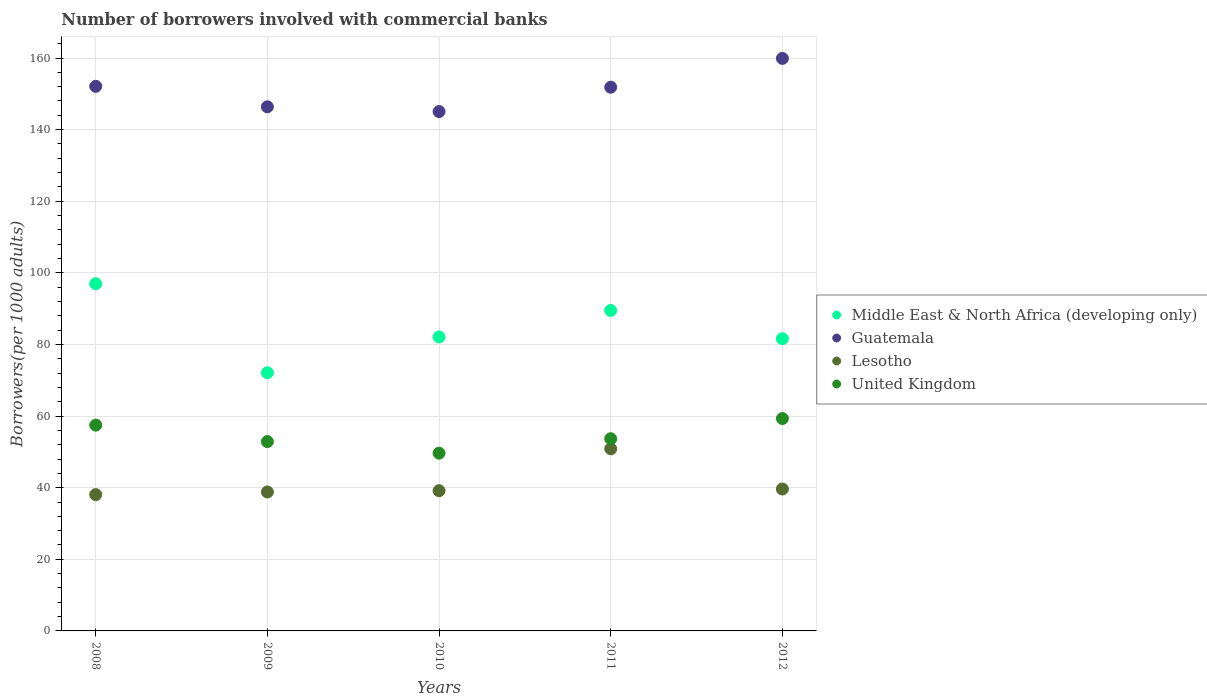How many different coloured dotlines are there?
Your response must be concise. 4. What is the number of borrowers involved with commercial banks in Guatemala in 2011?
Offer a very short reply. 151.85. Across all years, what is the maximum number of borrowers involved with commercial banks in Lesotho?
Your answer should be very brief. 50.87. Across all years, what is the minimum number of borrowers involved with commercial banks in United Kingdom?
Your response must be concise. 49.65. In which year was the number of borrowers involved with commercial banks in Lesotho minimum?
Your answer should be very brief. 2008. What is the total number of borrowers involved with commercial banks in United Kingdom in the graph?
Give a very brief answer. 273. What is the difference between the number of borrowers involved with commercial banks in Middle East & North Africa (developing only) in 2008 and that in 2010?
Provide a short and direct response. 14.86. What is the difference between the number of borrowers involved with commercial banks in Middle East & North Africa (developing only) in 2008 and the number of borrowers involved with commercial banks in Lesotho in 2012?
Ensure brevity in your answer.  57.33. What is the average number of borrowers involved with commercial banks in United Kingdom per year?
Provide a short and direct response. 54.6. In the year 2009, what is the difference between the number of borrowers involved with commercial banks in Lesotho and number of borrowers involved with commercial banks in Guatemala?
Your answer should be very brief. -107.56. In how many years, is the number of borrowers involved with commercial banks in Guatemala greater than 128?
Your answer should be very brief. 5. What is the ratio of the number of borrowers involved with commercial banks in Guatemala in 2011 to that in 2012?
Keep it short and to the point. 0.95. Is the difference between the number of borrowers involved with commercial banks in Lesotho in 2008 and 2012 greater than the difference between the number of borrowers involved with commercial banks in Guatemala in 2008 and 2012?
Provide a succinct answer. Yes. What is the difference between the highest and the second highest number of borrowers involved with commercial banks in Lesotho?
Offer a very short reply. 11.24. What is the difference between the highest and the lowest number of borrowers involved with commercial banks in Middle East & North Africa (developing only)?
Offer a terse response. 24.86. Is it the case that in every year, the sum of the number of borrowers involved with commercial banks in Lesotho and number of borrowers involved with commercial banks in Middle East & North Africa (developing only)  is greater than the sum of number of borrowers involved with commercial banks in United Kingdom and number of borrowers involved with commercial banks in Guatemala?
Give a very brief answer. No. Is the number of borrowers involved with commercial banks in Lesotho strictly greater than the number of borrowers involved with commercial banks in Middle East & North Africa (developing only) over the years?
Make the answer very short. No. Does the graph contain grids?
Make the answer very short. Yes. What is the title of the graph?
Your answer should be compact. Number of borrowers involved with commercial banks. Does "Turkey" appear as one of the legend labels in the graph?
Offer a terse response. No. What is the label or title of the Y-axis?
Your answer should be compact. Borrowers(per 1000 adults). What is the Borrowers(per 1000 adults) of Middle East & North Africa (developing only) in 2008?
Provide a succinct answer. 96.96. What is the Borrowers(per 1000 adults) of Guatemala in 2008?
Make the answer very short. 152.09. What is the Borrowers(per 1000 adults) of Lesotho in 2008?
Provide a short and direct response. 38.07. What is the Borrowers(per 1000 adults) of United Kingdom in 2008?
Provide a succinct answer. 57.47. What is the Borrowers(per 1000 adults) in Middle East & North Africa (developing only) in 2009?
Keep it short and to the point. 72.11. What is the Borrowers(per 1000 adults) of Guatemala in 2009?
Your answer should be very brief. 146.37. What is the Borrowers(per 1000 adults) in Lesotho in 2009?
Offer a terse response. 38.81. What is the Borrowers(per 1000 adults) in United Kingdom in 2009?
Your answer should be compact. 52.88. What is the Borrowers(per 1000 adults) of Middle East & North Africa (developing only) in 2010?
Provide a succinct answer. 82.1. What is the Borrowers(per 1000 adults) in Guatemala in 2010?
Offer a very short reply. 145.05. What is the Borrowers(per 1000 adults) of Lesotho in 2010?
Make the answer very short. 39.16. What is the Borrowers(per 1000 adults) of United Kingdom in 2010?
Provide a short and direct response. 49.65. What is the Borrowers(per 1000 adults) of Middle East & North Africa (developing only) in 2011?
Offer a very short reply. 89.5. What is the Borrowers(per 1000 adults) of Guatemala in 2011?
Give a very brief answer. 151.85. What is the Borrowers(per 1000 adults) in Lesotho in 2011?
Offer a very short reply. 50.87. What is the Borrowers(per 1000 adults) of United Kingdom in 2011?
Your answer should be compact. 53.68. What is the Borrowers(per 1000 adults) of Middle East & North Africa (developing only) in 2012?
Ensure brevity in your answer.  81.61. What is the Borrowers(per 1000 adults) in Guatemala in 2012?
Your answer should be compact. 159.9. What is the Borrowers(per 1000 adults) of Lesotho in 2012?
Keep it short and to the point. 39.63. What is the Borrowers(per 1000 adults) of United Kingdom in 2012?
Your answer should be very brief. 59.32. Across all years, what is the maximum Borrowers(per 1000 adults) of Middle East & North Africa (developing only)?
Your answer should be compact. 96.96. Across all years, what is the maximum Borrowers(per 1000 adults) in Guatemala?
Offer a very short reply. 159.9. Across all years, what is the maximum Borrowers(per 1000 adults) in Lesotho?
Your answer should be very brief. 50.87. Across all years, what is the maximum Borrowers(per 1000 adults) in United Kingdom?
Offer a terse response. 59.32. Across all years, what is the minimum Borrowers(per 1000 adults) in Middle East & North Africa (developing only)?
Provide a short and direct response. 72.11. Across all years, what is the minimum Borrowers(per 1000 adults) in Guatemala?
Give a very brief answer. 145.05. Across all years, what is the minimum Borrowers(per 1000 adults) of Lesotho?
Provide a succinct answer. 38.07. Across all years, what is the minimum Borrowers(per 1000 adults) of United Kingdom?
Give a very brief answer. 49.65. What is the total Borrowers(per 1000 adults) in Middle East & North Africa (developing only) in the graph?
Ensure brevity in your answer.  422.28. What is the total Borrowers(per 1000 adults) of Guatemala in the graph?
Make the answer very short. 755.26. What is the total Borrowers(per 1000 adults) in Lesotho in the graph?
Your answer should be very brief. 206.55. What is the total Borrowers(per 1000 adults) in United Kingdom in the graph?
Give a very brief answer. 273. What is the difference between the Borrowers(per 1000 adults) in Middle East & North Africa (developing only) in 2008 and that in 2009?
Ensure brevity in your answer.  24.86. What is the difference between the Borrowers(per 1000 adults) in Guatemala in 2008 and that in 2009?
Provide a succinct answer. 5.72. What is the difference between the Borrowers(per 1000 adults) of Lesotho in 2008 and that in 2009?
Offer a very short reply. -0.74. What is the difference between the Borrowers(per 1000 adults) in United Kingdom in 2008 and that in 2009?
Provide a short and direct response. 4.59. What is the difference between the Borrowers(per 1000 adults) of Middle East & North Africa (developing only) in 2008 and that in 2010?
Your answer should be compact. 14.86. What is the difference between the Borrowers(per 1000 adults) in Guatemala in 2008 and that in 2010?
Make the answer very short. 7.04. What is the difference between the Borrowers(per 1000 adults) of Lesotho in 2008 and that in 2010?
Provide a short and direct response. -1.09. What is the difference between the Borrowers(per 1000 adults) in United Kingdom in 2008 and that in 2010?
Provide a succinct answer. 7.83. What is the difference between the Borrowers(per 1000 adults) in Middle East & North Africa (developing only) in 2008 and that in 2011?
Ensure brevity in your answer.  7.46. What is the difference between the Borrowers(per 1000 adults) of Guatemala in 2008 and that in 2011?
Keep it short and to the point. 0.25. What is the difference between the Borrowers(per 1000 adults) in Lesotho in 2008 and that in 2011?
Your response must be concise. -12.8. What is the difference between the Borrowers(per 1000 adults) of United Kingdom in 2008 and that in 2011?
Give a very brief answer. 3.79. What is the difference between the Borrowers(per 1000 adults) of Middle East & North Africa (developing only) in 2008 and that in 2012?
Make the answer very short. 15.36. What is the difference between the Borrowers(per 1000 adults) in Guatemala in 2008 and that in 2012?
Ensure brevity in your answer.  -7.8. What is the difference between the Borrowers(per 1000 adults) in Lesotho in 2008 and that in 2012?
Provide a succinct answer. -1.56. What is the difference between the Borrowers(per 1000 adults) in United Kingdom in 2008 and that in 2012?
Ensure brevity in your answer.  -1.85. What is the difference between the Borrowers(per 1000 adults) in Middle East & North Africa (developing only) in 2009 and that in 2010?
Your answer should be compact. -10. What is the difference between the Borrowers(per 1000 adults) of Guatemala in 2009 and that in 2010?
Offer a very short reply. 1.32. What is the difference between the Borrowers(per 1000 adults) of Lesotho in 2009 and that in 2010?
Provide a succinct answer. -0.35. What is the difference between the Borrowers(per 1000 adults) in United Kingdom in 2009 and that in 2010?
Offer a terse response. 3.23. What is the difference between the Borrowers(per 1000 adults) in Middle East & North Africa (developing only) in 2009 and that in 2011?
Give a very brief answer. -17.4. What is the difference between the Borrowers(per 1000 adults) in Guatemala in 2009 and that in 2011?
Provide a succinct answer. -5.48. What is the difference between the Borrowers(per 1000 adults) of Lesotho in 2009 and that in 2011?
Ensure brevity in your answer.  -12.06. What is the difference between the Borrowers(per 1000 adults) of United Kingdom in 2009 and that in 2011?
Provide a short and direct response. -0.8. What is the difference between the Borrowers(per 1000 adults) of Middle East & North Africa (developing only) in 2009 and that in 2012?
Give a very brief answer. -9.5. What is the difference between the Borrowers(per 1000 adults) in Guatemala in 2009 and that in 2012?
Provide a succinct answer. -13.53. What is the difference between the Borrowers(per 1000 adults) in Lesotho in 2009 and that in 2012?
Offer a very short reply. -0.82. What is the difference between the Borrowers(per 1000 adults) of United Kingdom in 2009 and that in 2012?
Ensure brevity in your answer.  -6.44. What is the difference between the Borrowers(per 1000 adults) of Middle East & North Africa (developing only) in 2010 and that in 2011?
Your answer should be compact. -7.4. What is the difference between the Borrowers(per 1000 adults) in Guatemala in 2010 and that in 2011?
Keep it short and to the point. -6.8. What is the difference between the Borrowers(per 1000 adults) in Lesotho in 2010 and that in 2011?
Your answer should be compact. -11.71. What is the difference between the Borrowers(per 1000 adults) of United Kingdom in 2010 and that in 2011?
Keep it short and to the point. -4.03. What is the difference between the Borrowers(per 1000 adults) in Middle East & North Africa (developing only) in 2010 and that in 2012?
Offer a terse response. 0.5. What is the difference between the Borrowers(per 1000 adults) in Guatemala in 2010 and that in 2012?
Keep it short and to the point. -14.85. What is the difference between the Borrowers(per 1000 adults) in Lesotho in 2010 and that in 2012?
Provide a succinct answer. -0.47. What is the difference between the Borrowers(per 1000 adults) of United Kingdom in 2010 and that in 2012?
Provide a short and direct response. -9.67. What is the difference between the Borrowers(per 1000 adults) in Middle East & North Africa (developing only) in 2011 and that in 2012?
Give a very brief answer. 7.9. What is the difference between the Borrowers(per 1000 adults) of Guatemala in 2011 and that in 2012?
Provide a succinct answer. -8.05. What is the difference between the Borrowers(per 1000 adults) of Lesotho in 2011 and that in 2012?
Provide a succinct answer. 11.24. What is the difference between the Borrowers(per 1000 adults) in United Kingdom in 2011 and that in 2012?
Your response must be concise. -5.64. What is the difference between the Borrowers(per 1000 adults) in Middle East & North Africa (developing only) in 2008 and the Borrowers(per 1000 adults) in Guatemala in 2009?
Offer a terse response. -49.41. What is the difference between the Borrowers(per 1000 adults) of Middle East & North Africa (developing only) in 2008 and the Borrowers(per 1000 adults) of Lesotho in 2009?
Provide a short and direct response. 58.15. What is the difference between the Borrowers(per 1000 adults) of Middle East & North Africa (developing only) in 2008 and the Borrowers(per 1000 adults) of United Kingdom in 2009?
Make the answer very short. 44.08. What is the difference between the Borrowers(per 1000 adults) in Guatemala in 2008 and the Borrowers(per 1000 adults) in Lesotho in 2009?
Your answer should be compact. 113.28. What is the difference between the Borrowers(per 1000 adults) of Guatemala in 2008 and the Borrowers(per 1000 adults) of United Kingdom in 2009?
Your answer should be compact. 99.21. What is the difference between the Borrowers(per 1000 adults) of Lesotho in 2008 and the Borrowers(per 1000 adults) of United Kingdom in 2009?
Make the answer very short. -14.81. What is the difference between the Borrowers(per 1000 adults) in Middle East & North Africa (developing only) in 2008 and the Borrowers(per 1000 adults) in Guatemala in 2010?
Give a very brief answer. -48.09. What is the difference between the Borrowers(per 1000 adults) in Middle East & North Africa (developing only) in 2008 and the Borrowers(per 1000 adults) in Lesotho in 2010?
Your answer should be very brief. 57.8. What is the difference between the Borrowers(per 1000 adults) of Middle East & North Africa (developing only) in 2008 and the Borrowers(per 1000 adults) of United Kingdom in 2010?
Ensure brevity in your answer.  47.32. What is the difference between the Borrowers(per 1000 adults) in Guatemala in 2008 and the Borrowers(per 1000 adults) in Lesotho in 2010?
Your response must be concise. 112.93. What is the difference between the Borrowers(per 1000 adults) of Guatemala in 2008 and the Borrowers(per 1000 adults) of United Kingdom in 2010?
Offer a very short reply. 102.45. What is the difference between the Borrowers(per 1000 adults) of Lesotho in 2008 and the Borrowers(per 1000 adults) of United Kingdom in 2010?
Ensure brevity in your answer.  -11.58. What is the difference between the Borrowers(per 1000 adults) in Middle East & North Africa (developing only) in 2008 and the Borrowers(per 1000 adults) in Guatemala in 2011?
Your response must be concise. -54.88. What is the difference between the Borrowers(per 1000 adults) of Middle East & North Africa (developing only) in 2008 and the Borrowers(per 1000 adults) of Lesotho in 2011?
Your response must be concise. 46.09. What is the difference between the Borrowers(per 1000 adults) in Middle East & North Africa (developing only) in 2008 and the Borrowers(per 1000 adults) in United Kingdom in 2011?
Give a very brief answer. 43.28. What is the difference between the Borrowers(per 1000 adults) in Guatemala in 2008 and the Borrowers(per 1000 adults) in Lesotho in 2011?
Your response must be concise. 101.22. What is the difference between the Borrowers(per 1000 adults) of Guatemala in 2008 and the Borrowers(per 1000 adults) of United Kingdom in 2011?
Make the answer very short. 98.41. What is the difference between the Borrowers(per 1000 adults) in Lesotho in 2008 and the Borrowers(per 1000 adults) in United Kingdom in 2011?
Offer a terse response. -15.61. What is the difference between the Borrowers(per 1000 adults) of Middle East & North Africa (developing only) in 2008 and the Borrowers(per 1000 adults) of Guatemala in 2012?
Your answer should be very brief. -62.93. What is the difference between the Borrowers(per 1000 adults) of Middle East & North Africa (developing only) in 2008 and the Borrowers(per 1000 adults) of Lesotho in 2012?
Give a very brief answer. 57.33. What is the difference between the Borrowers(per 1000 adults) of Middle East & North Africa (developing only) in 2008 and the Borrowers(per 1000 adults) of United Kingdom in 2012?
Make the answer very short. 37.64. What is the difference between the Borrowers(per 1000 adults) in Guatemala in 2008 and the Borrowers(per 1000 adults) in Lesotho in 2012?
Keep it short and to the point. 112.46. What is the difference between the Borrowers(per 1000 adults) of Guatemala in 2008 and the Borrowers(per 1000 adults) of United Kingdom in 2012?
Provide a succinct answer. 92.77. What is the difference between the Borrowers(per 1000 adults) in Lesotho in 2008 and the Borrowers(per 1000 adults) in United Kingdom in 2012?
Make the answer very short. -21.25. What is the difference between the Borrowers(per 1000 adults) of Middle East & North Africa (developing only) in 2009 and the Borrowers(per 1000 adults) of Guatemala in 2010?
Your answer should be compact. -72.95. What is the difference between the Borrowers(per 1000 adults) in Middle East & North Africa (developing only) in 2009 and the Borrowers(per 1000 adults) in Lesotho in 2010?
Provide a succinct answer. 32.94. What is the difference between the Borrowers(per 1000 adults) of Middle East & North Africa (developing only) in 2009 and the Borrowers(per 1000 adults) of United Kingdom in 2010?
Your answer should be very brief. 22.46. What is the difference between the Borrowers(per 1000 adults) of Guatemala in 2009 and the Borrowers(per 1000 adults) of Lesotho in 2010?
Ensure brevity in your answer.  107.21. What is the difference between the Borrowers(per 1000 adults) of Guatemala in 2009 and the Borrowers(per 1000 adults) of United Kingdom in 2010?
Your answer should be very brief. 96.72. What is the difference between the Borrowers(per 1000 adults) in Lesotho in 2009 and the Borrowers(per 1000 adults) in United Kingdom in 2010?
Your response must be concise. -10.84. What is the difference between the Borrowers(per 1000 adults) of Middle East & North Africa (developing only) in 2009 and the Borrowers(per 1000 adults) of Guatemala in 2011?
Provide a succinct answer. -79.74. What is the difference between the Borrowers(per 1000 adults) in Middle East & North Africa (developing only) in 2009 and the Borrowers(per 1000 adults) in Lesotho in 2011?
Your answer should be compact. 21.23. What is the difference between the Borrowers(per 1000 adults) of Middle East & North Africa (developing only) in 2009 and the Borrowers(per 1000 adults) of United Kingdom in 2011?
Your answer should be compact. 18.43. What is the difference between the Borrowers(per 1000 adults) in Guatemala in 2009 and the Borrowers(per 1000 adults) in Lesotho in 2011?
Offer a very short reply. 95.5. What is the difference between the Borrowers(per 1000 adults) in Guatemala in 2009 and the Borrowers(per 1000 adults) in United Kingdom in 2011?
Your response must be concise. 92.69. What is the difference between the Borrowers(per 1000 adults) of Lesotho in 2009 and the Borrowers(per 1000 adults) of United Kingdom in 2011?
Your response must be concise. -14.87. What is the difference between the Borrowers(per 1000 adults) in Middle East & North Africa (developing only) in 2009 and the Borrowers(per 1000 adults) in Guatemala in 2012?
Provide a succinct answer. -87.79. What is the difference between the Borrowers(per 1000 adults) of Middle East & North Africa (developing only) in 2009 and the Borrowers(per 1000 adults) of Lesotho in 2012?
Offer a terse response. 32.47. What is the difference between the Borrowers(per 1000 adults) of Middle East & North Africa (developing only) in 2009 and the Borrowers(per 1000 adults) of United Kingdom in 2012?
Provide a succinct answer. 12.79. What is the difference between the Borrowers(per 1000 adults) in Guatemala in 2009 and the Borrowers(per 1000 adults) in Lesotho in 2012?
Keep it short and to the point. 106.74. What is the difference between the Borrowers(per 1000 adults) of Guatemala in 2009 and the Borrowers(per 1000 adults) of United Kingdom in 2012?
Your response must be concise. 87.05. What is the difference between the Borrowers(per 1000 adults) of Lesotho in 2009 and the Borrowers(per 1000 adults) of United Kingdom in 2012?
Ensure brevity in your answer.  -20.51. What is the difference between the Borrowers(per 1000 adults) in Middle East & North Africa (developing only) in 2010 and the Borrowers(per 1000 adults) in Guatemala in 2011?
Give a very brief answer. -69.75. What is the difference between the Borrowers(per 1000 adults) in Middle East & North Africa (developing only) in 2010 and the Borrowers(per 1000 adults) in Lesotho in 2011?
Your answer should be very brief. 31.23. What is the difference between the Borrowers(per 1000 adults) in Middle East & North Africa (developing only) in 2010 and the Borrowers(per 1000 adults) in United Kingdom in 2011?
Provide a succinct answer. 28.42. What is the difference between the Borrowers(per 1000 adults) in Guatemala in 2010 and the Borrowers(per 1000 adults) in Lesotho in 2011?
Your answer should be compact. 94.18. What is the difference between the Borrowers(per 1000 adults) of Guatemala in 2010 and the Borrowers(per 1000 adults) of United Kingdom in 2011?
Offer a very short reply. 91.37. What is the difference between the Borrowers(per 1000 adults) of Lesotho in 2010 and the Borrowers(per 1000 adults) of United Kingdom in 2011?
Your answer should be very brief. -14.52. What is the difference between the Borrowers(per 1000 adults) in Middle East & North Africa (developing only) in 2010 and the Borrowers(per 1000 adults) in Guatemala in 2012?
Provide a succinct answer. -77.79. What is the difference between the Borrowers(per 1000 adults) of Middle East & North Africa (developing only) in 2010 and the Borrowers(per 1000 adults) of Lesotho in 2012?
Offer a very short reply. 42.47. What is the difference between the Borrowers(per 1000 adults) of Middle East & North Africa (developing only) in 2010 and the Borrowers(per 1000 adults) of United Kingdom in 2012?
Your answer should be very brief. 22.78. What is the difference between the Borrowers(per 1000 adults) in Guatemala in 2010 and the Borrowers(per 1000 adults) in Lesotho in 2012?
Your answer should be compact. 105.42. What is the difference between the Borrowers(per 1000 adults) of Guatemala in 2010 and the Borrowers(per 1000 adults) of United Kingdom in 2012?
Make the answer very short. 85.73. What is the difference between the Borrowers(per 1000 adults) in Lesotho in 2010 and the Borrowers(per 1000 adults) in United Kingdom in 2012?
Provide a succinct answer. -20.16. What is the difference between the Borrowers(per 1000 adults) in Middle East & North Africa (developing only) in 2011 and the Borrowers(per 1000 adults) in Guatemala in 2012?
Provide a short and direct response. -70.4. What is the difference between the Borrowers(per 1000 adults) in Middle East & North Africa (developing only) in 2011 and the Borrowers(per 1000 adults) in Lesotho in 2012?
Your answer should be compact. 49.87. What is the difference between the Borrowers(per 1000 adults) in Middle East & North Africa (developing only) in 2011 and the Borrowers(per 1000 adults) in United Kingdom in 2012?
Give a very brief answer. 30.18. What is the difference between the Borrowers(per 1000 adults) in Guatemala in 2011 and the Borrowers(per 1000 adults) in Lesotho in 2012?
Your answer should be compact. 112.21. What is the difference between the Borrowers(per 1000 adults) in Guatemala in 2011 and the Borrowers(per 1000 adults) in United Kingdom in 2012?
Make the answer very short. 92.53. What is the difference between the Borrowers(per 1000 adults) of Lesotho in 2011 and the Borrowers(per 1000 adults) of United Kingdom in 2012?
Provide a short and direct response. -8.45. What is the average Borrowers(per 1000 adults) in Middle East & North Africa (developing only) per year?
Make the answer very short. 84.46. What is the average Borrowers(per 1000 adults) in Guatemala per year?
Your response must be concise. 151.05. What is the average Borrowers(per 1000 adults) of Lesotho per year?
Provide a short and direct response. 41.31. What is the average Borrowers(per 1000 adults) in United Kingdom per year?
Provide a short and direct response. 54.6. In the year 2008, what is the difference between the Borrowers(per 1000 adults) of Middle East & North Africa (developing only) and Borrowers(per 1000 adults) of Guatemala?
Your answer should be compact. -55.13. In the year 2008, what is the difference between the Borrowers(per 1000 adults) in Middle East & North Africa (developing only) and Borrowers(per 1000 adults) in Lesotho?
Ensure brevity in your answer.  58.89. In the year 2008, what is the difference between the Borrowers(per 1000 adults) of Middle East & North Africa (developing only) and Borrowers(per 1000 adults) of United Kingdom?
Your answer should be compact. 39.49. In the year 2008, what is the difference between the Borrowers(per 1000 adults) in Guatemala and Borrowers(per 1000 adults) in Lesotho?
Your answer should be very brief. 114.02. In the year 2008, what is the difference between the Borrowers(per 1000 adults) of Guatemala and Borrowers(per 1000 adults) of United Kingdom?
Provide a short and direct response. 94.62. In the year 2008, what is the difference between the Borrowers(per 1000 adults) of Lesotho and Borrowers(per 1000 adults) of United Kingdom?
Offer a very short reply. -19.4. In the year 2009, what is the difference between the Borrowers(per 1000 adults) of Middle East & North Africa (developing only) and Borrowers(per 1000 adults) of Guatemala?
Keep it short and to the point. -74.27. In the year 2009, what is the difference between the Borrowers(per 1000 adults) in Middle East & North Africa (developing only) and Borrowers(per 1000 adults) in Lesotho?
Make the answer very short. 33.3. In the year 2009, what is the difference between the Borrowers(per 1000 adults) of Middle East & North Africa (developing only) and Borrowers(per 1000 adults) of United Kingdom?
Keep it short and to the point. 19.23. In the year 2009, what is the difference between the Borrowers(per 1000 adults) of Guatemala and Borrowers(per 1000 adults) of Lesotho?
Your response must be concise. 107.56. In the year 2009, what is the difference between the Borrowers(per 1000 adults) in Guatemala and Borrowers(per 1000 adults) in United Kingdom?
Give a very brief answer. 93.49. In the year 2009, what is the difference between the Borrowers(per 1000 adults) in Lesotho and Borrowers(per 1000 adults) in United Kingdom?
Your answer should be very brief. -14.07. In the year 2010, what is the difference between the Borrowers(per 1000 adults) in Middle East & North Africa (developing only) and Borrowers(per 1000 adults) in Guatemala?
Offer a very short reply. -62.95. In the year 2010, what is the difference between the Borrowers(per 1000 adults) in Middle East & North Africa (developing only) and Borrowers(per 1000 adults) in Lesotho?
Keep it short and to the point. 42.94. In the year 2010, what is the difference between the Borrowers(per 1000 adults) in Middle East & North Africa (developing only) and Borrowers(per 1000 adults) in United Kingdom?
Keep it short and to the point. 32.45. In the year 2010, what is the difference between the Borrowers(per 1000 adults) in Guatemala and Borrowers(per 1000 adults) in Lesotho?
Offer a terse response. 105.89. In the year 2010, what is the difference between the Borrowers(per 1000 adults) in Guatemala and Borrowers(per 1000 adults) in United Kingdom?
Give a very brief answer. 95.4. In the year 2010, what is the difference between the Borrowers(per 1000 adults) of Lesotho and Borrowers(per 1000 adults) of United Kingdom?
Your answer should be very brief. -10.49. In the year 2011, what is the difference between the Borrowers(per 1000 adults) of Middle East & North Africa (developing only) and Borrowers(per 1000 adults) of Guatemala?
Give a very brief answer. -62.35. In the year 2011, what is the difference between the Borrowers(per 1000 adults) in Middle East & North Africa (developing only) and Borrowers(per 1000 adults) in Lesotho?
Keep it short and to the point. 38.63. In the year 2011, what is the difference between the Borrowers(per 1000 adults) of Middle East & North Africa (developing only) and Borrowers(per 1000 adults) of United Kingdom?
Offer a terse response. 35.82. In the year 2011, what is the difference between the Borrowers(per 1000 adults) in Guatemala and Borrowers(per 1000 adults) in Lesotho?
Offer a terse response. 100.98. In the year 2011, what is the difference between the Borrowers(per 1000 adults) of Guatemala and Borrowers(per 1000 adults) of United Kingdom?
Your response must be concise. 98.17. In the year 2011, what is the difference between the Borrowers(per 1000 adults) in Lesotho and Borrowers(per 1000 adults) in United Kingdom?
Your response must be concise. -2.81. In the year 2012, what is the difference between the Borrowers(per 1000 adults) of Middle East & North Africa (developing only) and Borrowers(per 1000 adults) of Guatemala?
Your answer should be compact. -78.29. In the year 2012, what is the difference between the Borrowers(per 1000 adults) of Middle East & North Africa (developing only) and Borrowers(per 1000 adults) of Lesotho?
Your response must be concise. 41.97. In the year 2012, what is the difference between the Borrowers(per 1000 adults) in Middle East & North Africa (developing only) and Borrowers(per 1000 adults) in United Kingdom?
Your response must be concise. 22.28. In the year 2012, what is the difference between the Borrowers(per 1000 adults) in Guatemala and Borrowers(per 1000 adults) in Lesotho?
Ensure brevity in your answer.  120.26. In the year 2012, what is the difference between the Borrowers(per 1000 adults) in Guatemala and Borrowers(per 1000 adults) in United Kingdom?
Give a very brief answer. 100.58. In the year 2012, what is the difference between the Borrowers(per 1000 adults) of Lesotho and Borrowers(per 1000 adults) of United Kingdom?
Offer a terse response. -19.69. What is the ratio of the Borrowers(per 1000 adults) in Middle East & North Africa (developing only) in 2008 to that in 2009?
Provide a short and direct response. 1.34. What is the ratio of the Borrowers(per 1000 adults) in Guatemala in 2008 to that in 2009?
Give a very brief answer. 1.04. What is the ratio of the Borrowers(per 1000 adults) in Lesotho in 2008 to that in 2009?
Your answer should be very brief. 0.98. What is the ratio of the Borrowers(per 1000 adults) in United Kingdom in 2008 to that in 2009?
Offer a terse response. 1.09. What is the ratio of the Borrowers(per 1000 adults) in Middle East & North Africa (developing only) in 2008 to that in 2010?
Make the answer very short. 1.18. What is the ratio of the Borrowers(per 1000 adults) in Guatemala in 2008 to that in 2010?
Your answer should be very brief. 1.05. What is the ratio of the Borrowers(per 1000 adults) in Lesotho in 2008 to that in 2010?
Keep it short and to the point. 0.97. What is the ratio of the Borrowers(per 1000 adults) of United Kingdom in 2008 to that in 2010?
Give a very brief answer. 1.16. What is the ratio of the Borrowers(per 1000 adults) in Middle East & North Africa (developing only) in 2008 to that in 2011?
Offer a very short reply. 1.08. What is the ratio of the Borrowers(per 1000 adults) in Guatemala in 2008 to that in 2011?
Make the answer very short. 1. What is the ratio of the Borrowers(per 1000 adults) of Lesotho in 2008 to that in 2011?
Provide a short and direct response. 0.75. What is the ratio of the Borrowers(per 1000 adults) of United Kingdom in 2008 to that in 2011?
Your response must be concise. 1.07. What is the ratio of the Borrowers(per 1000 adults) of Middle East & North Africa (developing only) in 2008 to that in 2012?
Make the answer very short. 1.19. What is the ratio of the Borrowers(per 1000 adults) in Guatemala in 2008 to that in 2012?
Give a very brief answer. 0.95. What is the ratio of the Borrowers(per 1000 adults) of Lesotho in 2008 to that in 2012?
Your answer should be compact. 0.96. What is the ratio of the Borrowers(per 1000 adults) in United Kingdom in 2008 to that in 2012?
Your answer should be very brief. 0.97. What is the ratio of the Borrowers(per 1000 adults) in Middle East & North Africa (developing only) in 2009 to that in 2010?
Provide a short and direct response. 0.88. What is the ratio of the Borrowers(per 1000 adults) of Guatemala in 2009 to that in 2010?
Offer a very short reply. 1.01. What is the ratio of the Borrowers(per 1000 adults) in United Kingdom in 2009 to that in 2010?
Make the answer very short. 1.07. What is the ratio of the Borrowers(per 1000 adults) in Middle East & North Africa (developing only) in 2009 to that in 2011?
Your answer should be compact. 0.81. What is the ratio of the Borrowers(per 1000 adults) of Guatemala in 2009 to that in 2011?
Your answer should be compact. 0.96. What is the ratio of the Borrowers(per 1000 adults) in Lesotho in 2009 to that in 2011?
Offer a terse response. 0.76. What is the ratio of the Borrowers(per 1000 adults) of United Kingdom in 2009 to that in 2011?
Provide a short and direct response. 0.99. What is the ratio of the Borrowers(per 1000 adults) of Middle East & North Africa (developing only) in 2009 to that in 2012?
Your response must be concise. 0.88. What is the ratio of the Borrowers(per 1000 adults) of Guatemala in 2009 to that in 2012?
Keep it short and to the point. 0.92. What is the ratio of the Borrowers(per 1000 adults) of Lesotho in 2009 to that in 2012?
Your response must be concise. 0.98. What is the ratio of the Borrowers(per 1000 adults) of United Kingdom in 2009 to that in 2012?
Offer a very short reply. 0.89. What is the ratio of the Borrowers(per 1000 adults) of Middle East & North Africa (developing only) in 2010 to that in 2011?
Keep it short and to the point. 0.92. What is the ratio of the Borrowers(per 1000 adults) in Guatemala in 2010 to that in 2011?
Offer a very short reply. 0.96. What is the ratio of the Borrowers(per 1000 adults) in Lesotho in 2010 to that in 2011?
Make the answer very short. 0.77. What is the ratio of the Borrowers(per 1000 adults) in United Kingdom in 2010 to that in 2011?
Ensure brevity in your answer.  0.92. What is the ratio of the Borrowers(per 1000 adults) of Middle East & North Africa (developing only) in 2010 to that in 2012?
Make the answer very short. 1.01. What is the ratio of the Borrowers(per 1000 adults) in Guatemala in 2010 to that in 2012?
Keep it short and to the point. 0.91. What is the ratio of the Borrowers(per 1000 adults) of United Kingdom in 2010 to that in 2012?
Ensure brevity in your answer.  0.84. What is the ratio of the Borrowers(per 1000 adults) of Middle East & North Africa (developing only) in 2011 to that in 2012?
Your response must be concise. 1.1. What is the ratio of the Borrowers(per 1000 adults) in Guatemala in 2011 to that in 2012?
Keep it short and to the point. 0.95. What is the ratio of the Borrowers(per 1000 adults) in Lesotho in 2011 to that in 2012?
Offer a very short reply. 1.28. What is the ratio of the Borrowers(per 1000 adults) of United Kingdom in 2011 to that in 2012?
Offer a terse response. 0.9. What is the difference between the highest and the second highest Borrowers(per 1000 adults) in Middle East & North Africa (developing only)?
Ensure brevity in your answer.  7.46. What is the difference between the highest and the second highest Borrowers(per 1000 adults) of Guatemala?
Your answer should be very brief. 7.8. What is the difference between the highest and the second highest Borrowers(per 1000 adults) in Lesotho?
Keep it short and to the point. 11.24. What is the difference between the highest and the second highest Borrowers(per 1000 adults) of United Kingdom?
Provide a succinct answer. 1.85. What is the difference between the highest and the lowest Borrowers(per 1000 adults) of Middle East & North Africa (developing only)?
Your response must be concise. 24.86. What is the difference between the highest and the lowest Borrowers(per 1000 adults) of Guatemala?
Provide a succinct answer. 14.85. What is the difference between the highest and the lowest Borrowers(per 1000 adults) of Lesotho?
Your answer should be compact. 12.8. What is the difference between the highest and the lowest Borrowers(per 1000 adults) of United Kingdom?
Provide a succinct answer. 9.67. 